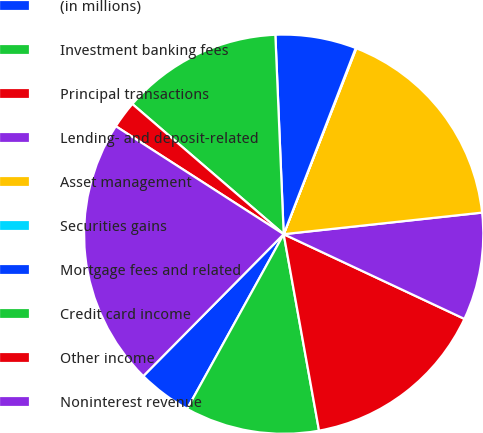Convert chart. <chart><loc_0><loc_0><loc_500><loc_500><pie_chart><fcel>(in millions)<fcel>Investment banking fees<fcel>Principal transactions<fcel>Lending- and deposit-related<fcel>Asset management<fcel>Securities gains<fcel>Mortgage fees and related<fcel>Credit card income<fcel>Other income<fcel>Noninterest revenue<nl><fcel>4.38%<fcel>10.87%<fcel>15.19%<fcel>8.7%<fcel>17.35%<fcel>0.05%<fcel>6.54%<fcel>13.03%<fcel>2.21%<fcel>21.68%<nl></chart> 